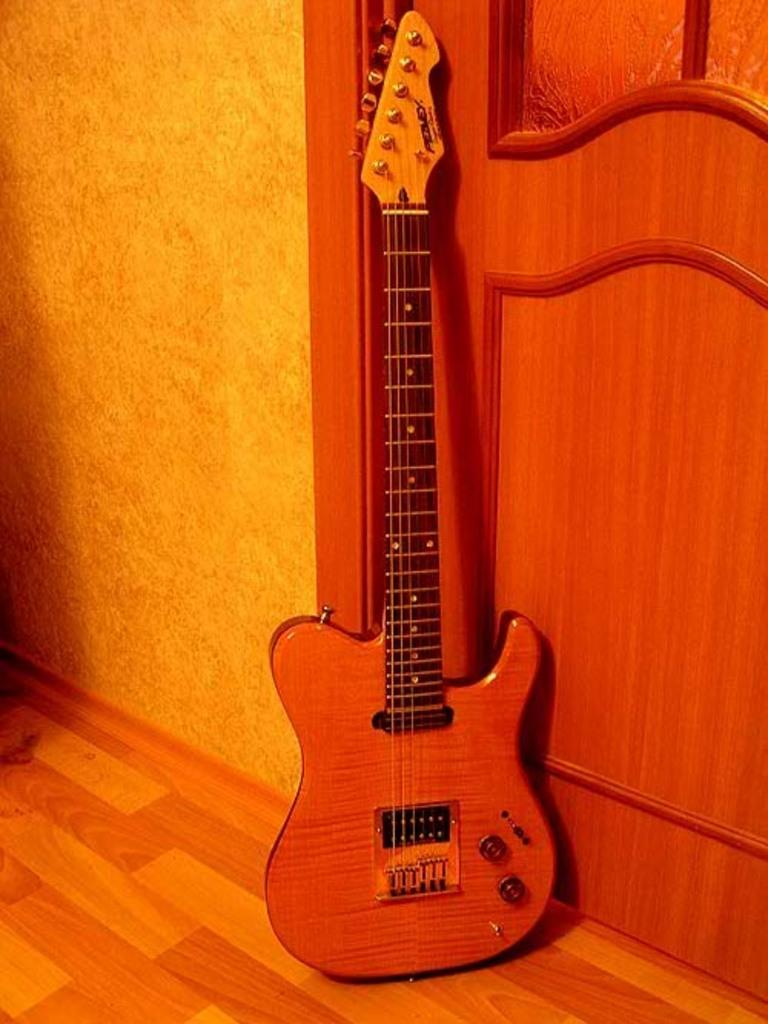What type of guitar is in the image? There is a brown color guitar in the image. Where is the guitar placed? The guitar is placed on the wooden flooring. What other wooden object can be seen in the image? There is a wooden door visible in the image. What type of disgust can be seen on the monkey's face in the image? There is no monkey present in the image, so it is not possible to determine any emotions or expressions on its face. 